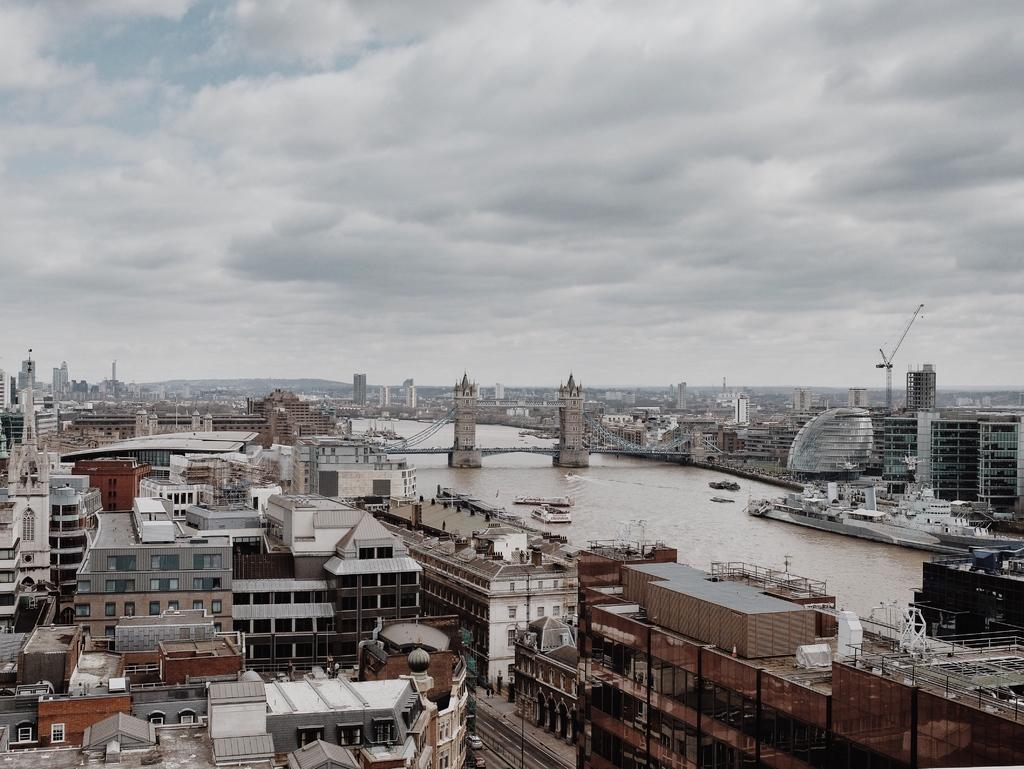Describe this image in one or two sentences. This is the top view of London city. In the middle of the image there is a bridge on Thames river, besides the river there are buildings. In the background of the image there are mountains. At the top of the image there are clouds in the sky. 